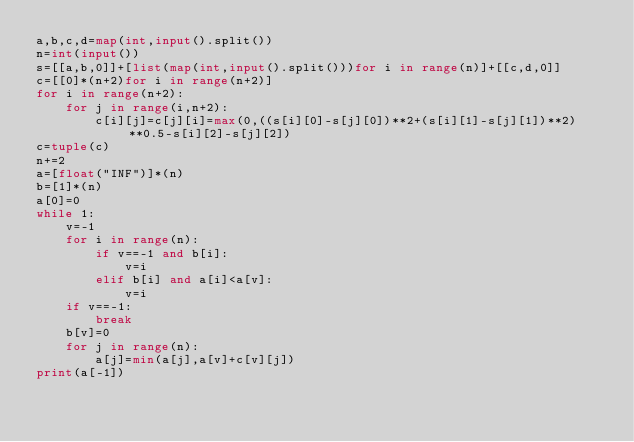Convert code to text. <code><loc_0><loc_0><loc_500><loc_500><_Python_>a,b,c,d=map(int,input().split())
n=int(input())
s=[[a,b,0]]+[list(map(int,input().split()))for i in range(n)]+[[c,d,0]]
c=[[0]*(n+2)for i in range(n+2)]
for i in range(n+2):
    for j in range(i,n+2):
        c[i][j]=c[j][i]=max(0,((s[i][0]-s[j][0])**2+(s[i][1]-s[j][1])**2)**0.5-s[i][2]-s[j][2])
c=tuple(c)
n+=2
a=[float("INF")]*(n)
b=[1]*(n)
a[0]=0
while 1:
    v=-1
    for i in range(n):
        if v==-1 and b[i]:
            v=i
        elif b[i] and a[i]<a[v]:
            v=i
    if v==-1:
        break
    b[v]=0
    for j in range(n):
        a[j]=min(a[j],a[v]+c[v][j])
print(a[-1])</code> 